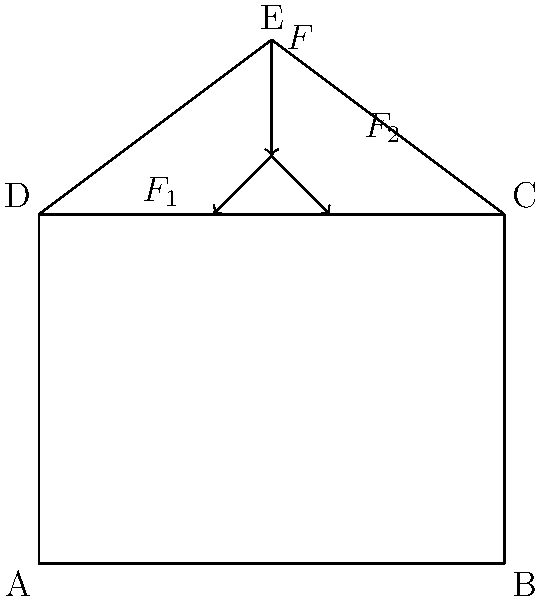In the context of ancient religious architecture, consider a simplified force diagram of a Gothic cathedral's roof structure as shown. The vertical force $F$ represents the weight of the roof acting on point E. This force is distributed to the side walls through forces $F_1$ and $F_2$. If the angle between $F_1$ (or $F_2$) and the horizontal is 30°, express $F_1$ in terms of $F$. To solve this problem, we'll follow these steps:

1) First, we need to understand that the vertical force $F$ is split into two equal components $F_1$ and $F_2$ due to the symmetry of the structure.

2) We can use trigonometry to relate $F_1$ to $F$. The vertical component of $F_1$ is what contributes to supporting $F$.

3) The vertical component of $F_1$ is given by $F_1 \sin(30°)$.

4) Since there are two equal forces ($F_1$ and $F_2$), we can write:

   $F = 2F_1 \sin(30°)$

5) We want to express $F_1$ in terms of $F$, so let's solve this equation for $F_1$:

   $F_1 = \frac{F}{2\sin(30°)}$

6) We know that $\sin(30°) = \frac{1}{2}$, so we can simplify:

   $F_1 = \frac{F}{2(\frac{1}{2})} = \frac{F}{1} = F$

Therefore, each of the angled forces $F_1$ and $F_2$ is equal in magnitude to the vertical force $F$.
Answer: $F_1 = F$ 